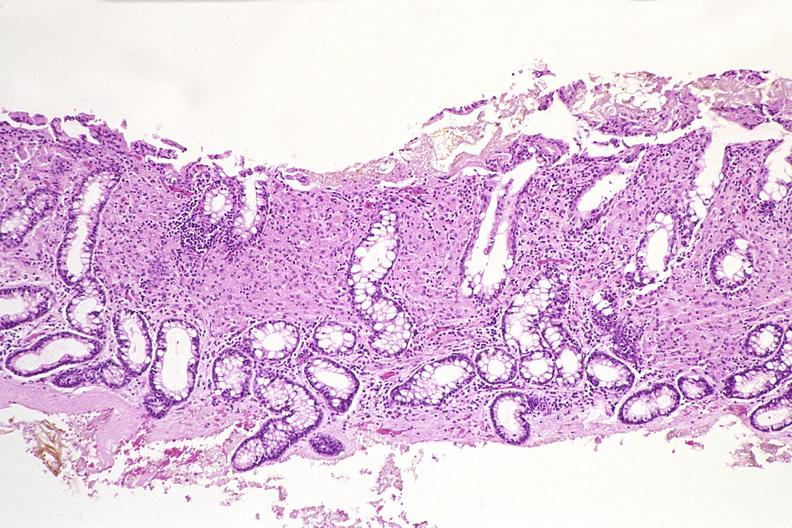does this image show colon biopsy, mycobacterium avium-intracellularae?
Answer the question using a single word or phrase. Yes 